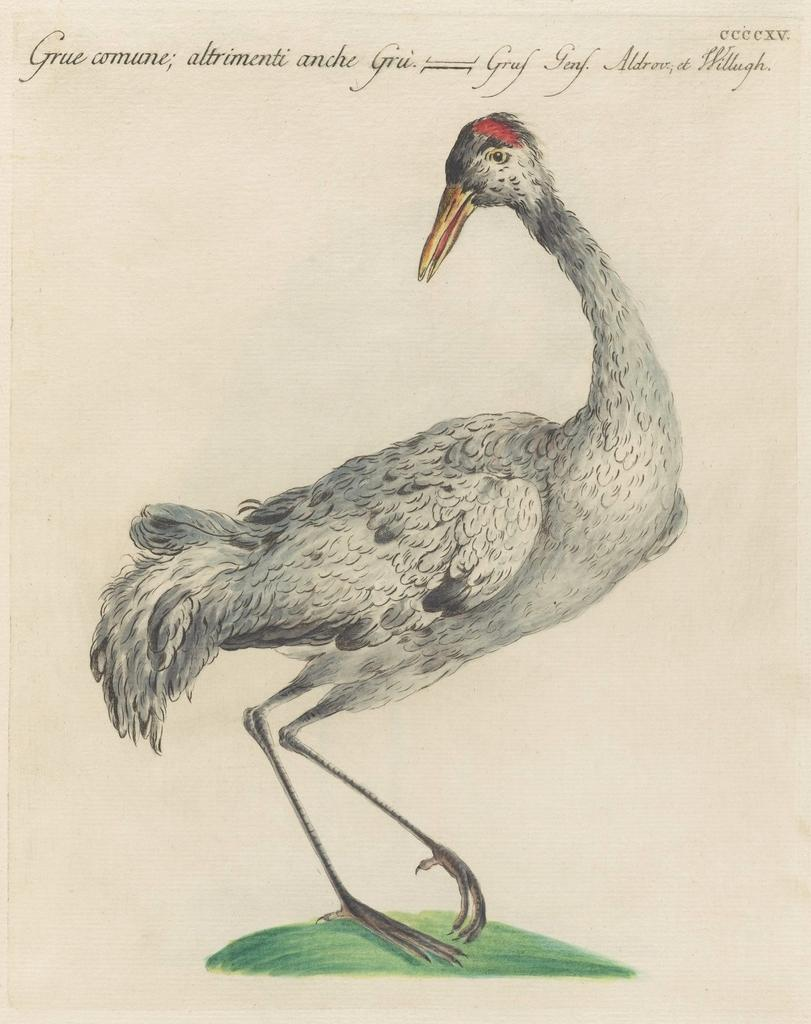What is depicted on the paper in the image? There is a picture of a bird on a paper in the image. What else can be seen at the top of the image? There is text at the top of the image. What type of mint is being used to plough the field in the image? There is no mint or plough present in the image; it only features a picture of a bird on a paper and text at the top. 